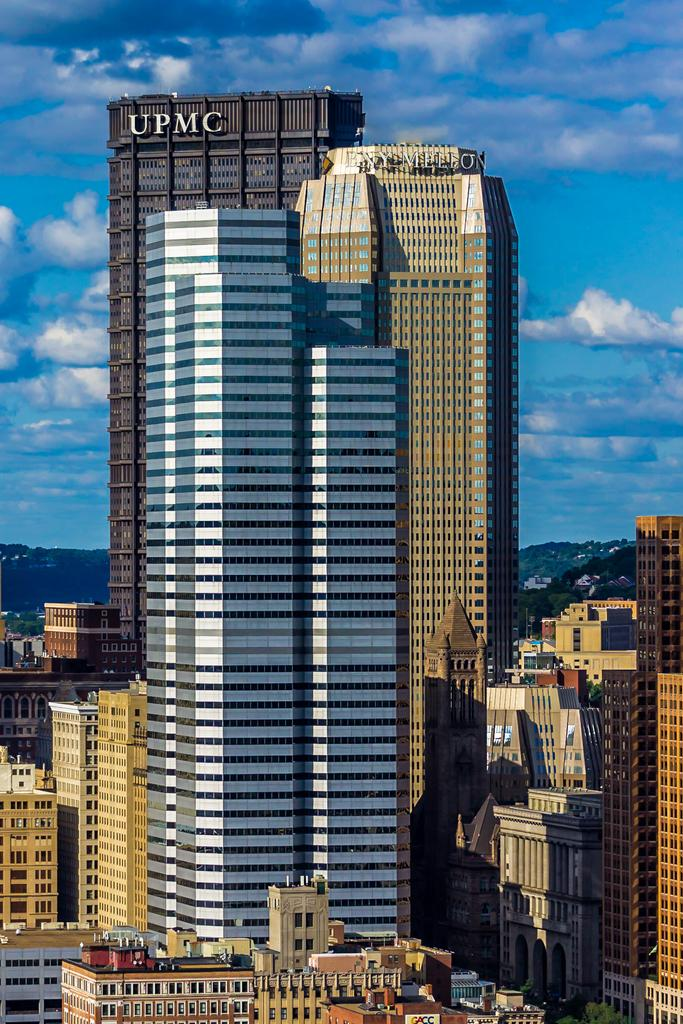What type of structures are present in the image? There are buildings in the image. Can you describe the colors of the buildings? The buildings have white, cream, brown, and gray colors. What can be seen in the background of the image? The sky is visible in the background of the image. What colors are present in the sky? The sky has blue and white colors. What flavor of notebook can be seen in the image? There is no notebook present in the image, so it is not possible to determine its flavor. 